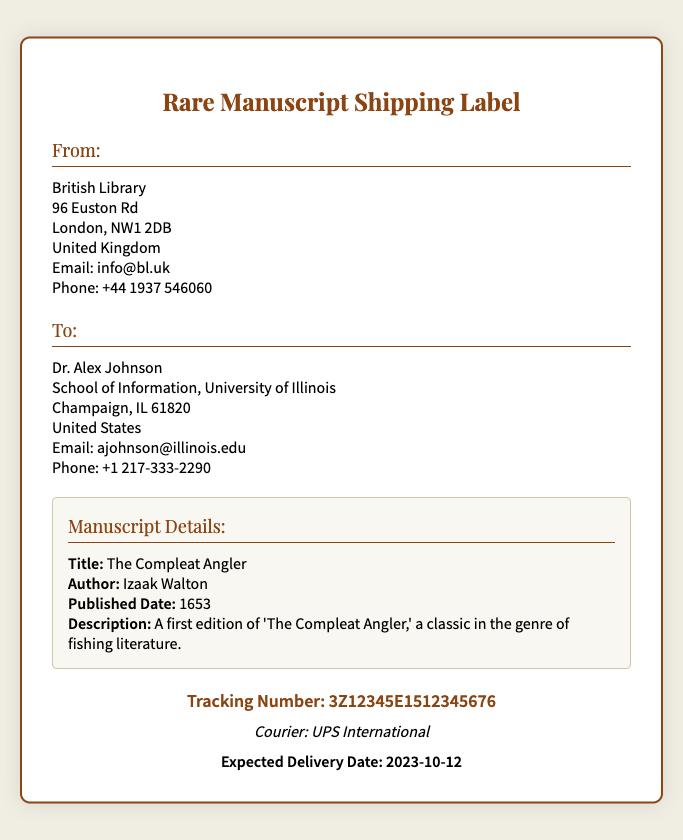What is the title of the manuscript? The title of the manuscript can be found in the manuscript details section of the document.
Answer: The Compleat Angler Who is the author of the manuscript? The author's name is listed in the manuscript details section of the shipping label.
Answer: Izaak Walton What is the tracking number? The tracking number is presented prominently in the shipping label.
Answer: 3Z12345E1512345676 What is the expected delivery date? The expected delivery date is highlighted in the delivery date section of the document.
Answer: 2023-10-12 Which courier is being used for shipping? The courier information is stated below the tracking number on the label.
Answer: UPS International Where is the sender located? The sender's address is provided in the "From" section of the shipping label.
Answer: British Library, 96 Euston Rd, London, NW1 2DB, United Kingdom What type of document is this? This document serves as a shipping label for a rare manuscript.
Answer: Shipping label What year was the manuscript published? The published date of the manuscript is listed in the manuscript details.
Answer: 1653 Who is the recipient? The recipient's name is specified in the "To" section of the shipping label.
Answer: Dr. Alex Johnson 